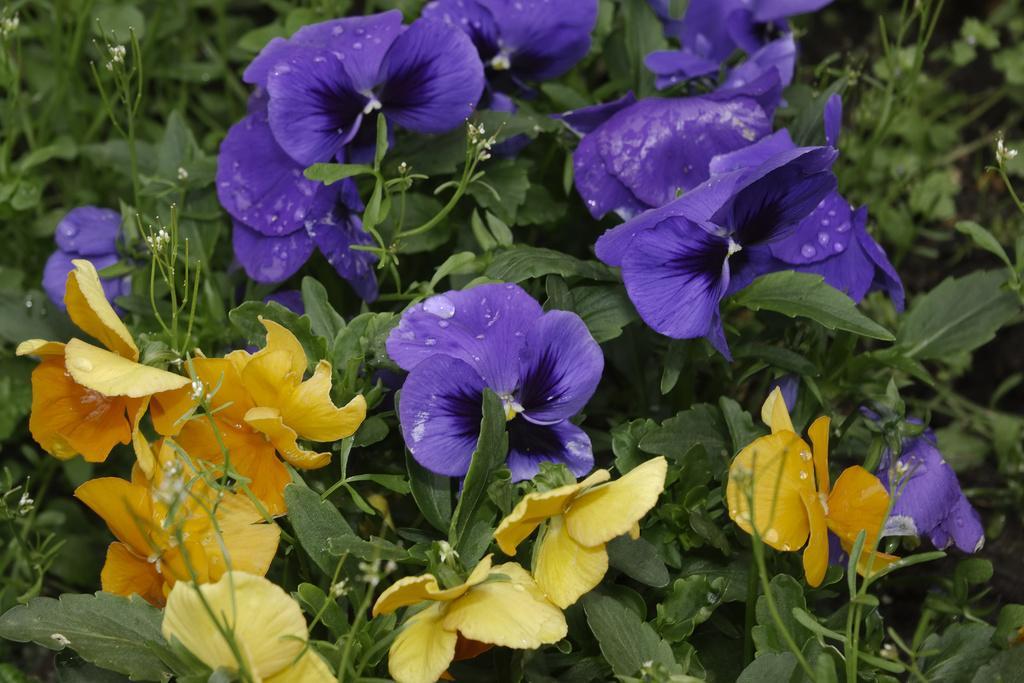Can you describe this image briefly? There are flowers in this image with the leaves in the background. The flowers are yellow in colour and purple in colour. 